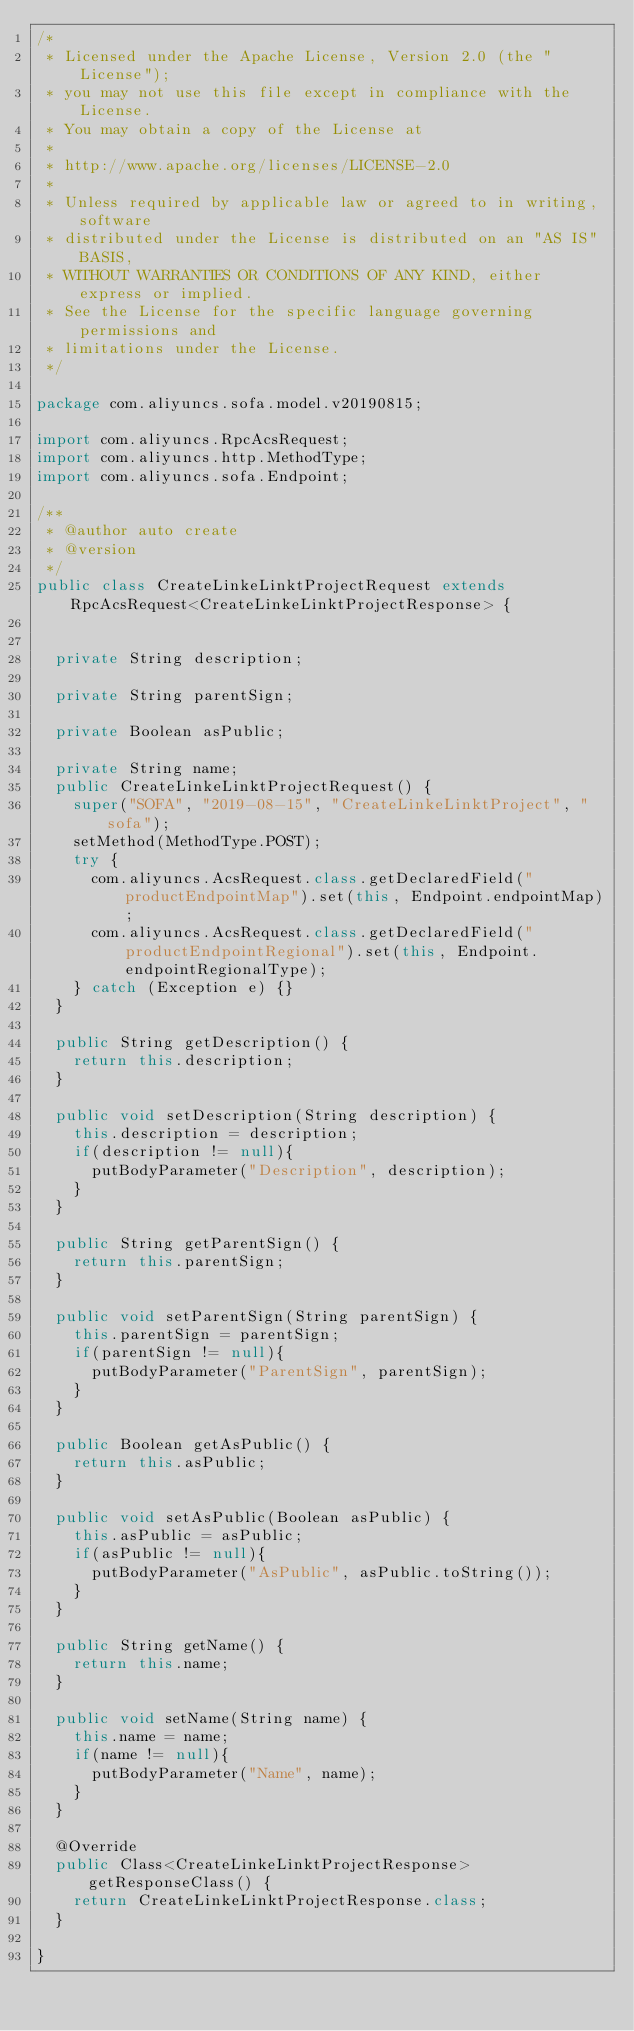<code> <loc_0><loc_0><loc_500><loc_500><_Java_>/*
 * Licensed under the Apache License, Version 2.0 (the "License");
 * you may not use this file except in compliance with the License.
 * You may obtain a copy of the License at
 *
 * http://www.apache.org/licenses/LICENSE-2.0
 *
 * Unless required by applicable law or agreed to in writing, software
 * distributed under the License is distributed on an "AS IS" BASIS,
 * WITHOUT WARRANTIES OR CONDITIONS OF ANY KIND, either express or implied.
 * See the License for the specific language governing permissions and
 * limitations under the License.
 */

package com.aliyuncs.sofa.model.v20190815;

import com.aliyuncs.RpcAcsRequest;
import com.aliyuncs.http.MethodType;
import com.aliyuncs.sofa.Endpoint;

/**
 * @author auto create
 * @version 
 */
public class CreateLinkeLinktProjectRequest extends RpcAcsRequest<CreateLinkeLinktProjectResponse> {
	   

	private String description;

	private String parentSign;

	private Boolean asPublic;

	private String name;
	public CreateLinkeLinktProjectRequest() {
		super("SOFA", "2019-08-15", "CreateLinkeLinktProject", "sofa");
		setMethod(MethodType.POST);
		try {
			com.aliyuncs.AcsRequest.class.getDeclaredField("productEndpointMap").set(this, Endpoint.endpointMap);
			com.aliyuncs.AcsRequest.class.getDeclaredField("productEndpointRegional").set(this, Endpoint.endpointRegionalType);
		} catch (Exception e) {}
	}

	public String getDescription() {
		return this.description;
	}

	public void setDescription(String description) {
		this.description = description;
		if(description != null){
			putBodyParameter("Description", description);
		}
	}

	public String getParentSign() {
		return this.parentSign;
	}

	public void setParentSign(String parentSign) {
		this.parentSign = parentSign;
		if(parentSign != null){
			putBodyParameter("ParentSign", parentSign);
		}
	}

	public Boolean getAsPublic() {
		return this.asPublic;
	}

	public void setAsPublic(Boolean asPublic) {
		this.asPublic = asPublic;
		if(asPublic != null){
			putBodyParameter("AsPublic", asPublic.toString());
		}
	}

	public String getName() {
		return this.name;
	}

	public void setName(String name) {
		this.name = name;
		if(name != null){
			putBodyParameter("Name", name);
		}
	}

	@Override
	public Class<CreateLinkeLinktProjectResponse> getResponseClass() {
		return CreateLinkeLinktProjectResponse.class;
	}

}
</code> 